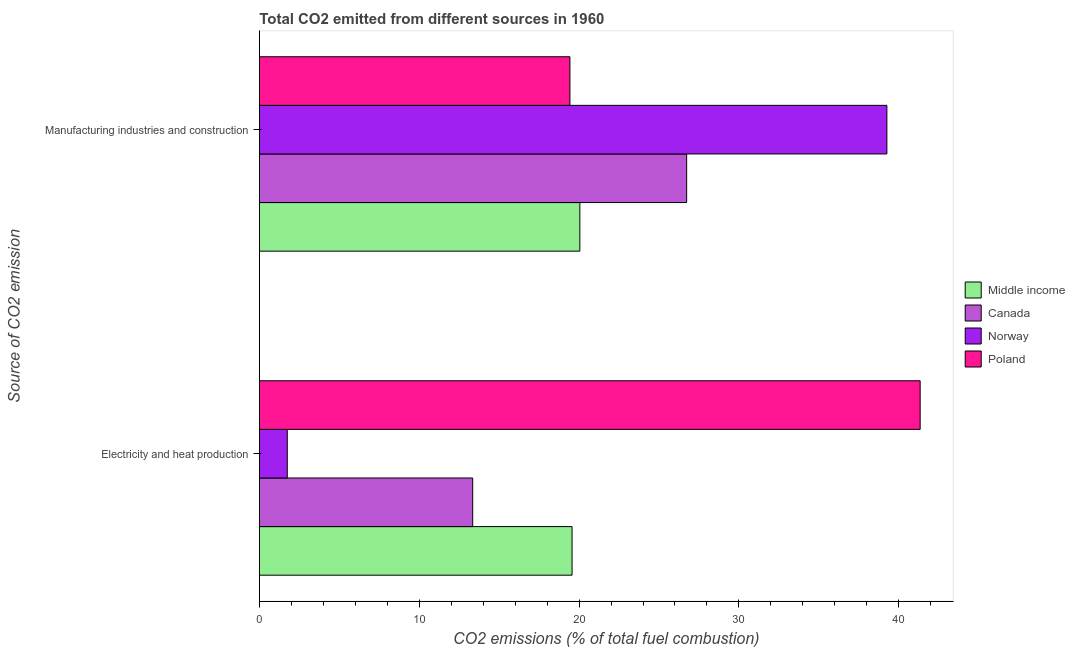How many groups of bars are there?
Your answer should be very brief. 2. Are the number of bars per tick equal to the number of legend labels?
Make the answer very short. Yes. Are the number of bars on each tick of the Y-axis equal?
Your response must be concise. Yes. How many bars are there on the 2nd tick from the top?
Provide a succinct answer. 4. What is the label of the 1st group of bars from the top?
Offer a terse response. Manufacturing industries and construction. What is the co2 emissions due to electricity and heat production in Norway?
Provide a succinct answer. 1.75. Across all countries, what is the maximum co2 emissions due to electricity and heat production?
Offer a very short reply. 41.34. Across all countries, what is the minimum co2 emissions due to electricity and heat production?
Provide a succinct answer. 1.75. What is the total co2 emissions due to manufacturing industries in the graph?
Keep it short and to the point. 105.46. What is the difference between the co2 emissions due to electricity and heat production in Middle income and that in Poland?
Offer a very short reply. -21.77. What is the difference between the co2 emissions due to electricity and heat production in Poland and the co2 emissions due to manufacturing industries in Norway?
Your answer should be compact. 2.08. What is the average co2 emissions due to electricity and heat production per country?
Ensure brevity in your answer.  19. What is the difference between the co2 emissions due to electricity and heat production and co2 emissions due to manufacturing industries in Poland?
Ensure brevity in your answer.  21.91. In how many countries, is the co2 emissions due to electricity and heat production greater than 28 %?
Give a very brief answer. 1. What is the ratio of the co2 emissions due to electricity and heat production in Middle income to that in Poland?
Your response must be concise. 0.47. Is the co2 emissions due to electricity and heat production in Poland less than that in Norway?
Provide a short and direct response. No. In how many countries, is the co2 emissions due to manufacturing industries greater than the average co2 emissions due to manufacturing industries taken over all countries?
Your answer should be very brief. 2. What does the 3rd bar from the top in Electricity and heat production represents?
Your answer should be compact. Canada. What does the 3rd bar from the bottom in Electricity and heat production represents?
Your answer should be very brief. Norway. Are all the bars in the graph horizontal?
Keep it short and to the point. Yes. How many countries are there in the graph?
Ensure brevity in your answer.  4. What is the difference between two consecutive major ticks on the X-axis?
Your response must be concise. 10. Are the values on the major ticks of X-axis written in scientific E-notation?
Offer a terse response. No. Does the graph contain any zero values?
Your response must be concise. No. How many legend labels are there?
Make the answer very short. 4. What is the title of the graph?
Your response must be concise. Total CO2 emitted from different sources in 1960. What is the label or title of the X-axis?
Make the answer very short. CO2 emissions (% of total fuel combustion). What is the label or title of the Y-axis?
Your response must be concise. Source of CO2 emission. What is the CO2 emissions (% of total fuel combustion) of Middle income in Electricity and heat production?
Your answer should be very brief. 19.56. What is the CO2 emissions (% of total fuel combustion) in Canada in Electricity and heat production?
Keep it short and to the point. 13.35. What is the CO2 emissions (% of total fuel combustion) in Norway in Electricity and heat production?
Provide a short and direct response. 1.75. What is the CO2 emissions (% of total fuel combustion) of Poland in Electricity and heat production?
Provide a short and direct response. 41.34. What is the CO2 emissions (% of total fuel combustion) in Middle income in Manufacturing industries and construction?
Give a very brief answer. 20.05. What is the CO2 emissions (% of total fuel combustion) in Canada in Manufacturing industries and construction?
Offer a terse response. 26.73. What is the CO2 emissions (% of total fuel combustion) of Norway in Manufacturing industries and construction?
Your answer should be compact. 39.26. What is the CO2 emissions (% of total fuel combustion) of Poland in Manufacturing industries and construction?
Give a very brief answer. 19.43. Across all Source of CO2 emission, what is the maximum CO2 emissions (% of total fuel combustion) of Middle income?
Offer a very short reply. 20.05. Across all Source of CO2 emission, what is the maximum CO2 emissions (% of total fuel combustion) in Canada?
Provide a short and direct response. 26.73. Across all Source of CO2 emission, what is the maximum CO2 emissions (% of total fuel combustion) of Norway?
Provide a succinct answer. 39.26. Across all Source of CO2 emission, what is the maximum CO2 emissions (% of total fuel combustion) of Poland?
Your answer should be very brief. 41.34. Across all Source of CO2 emission, what is the minimum CO2 emissions (% of total fuel combustion) of Middle income?
Provide a succinct answer. 19.56. Across all Source of CO2 emission, what is the minimum CO2 emissions (% of total fuel combustion) in Canada?
Keep it short and to the point. 13.35. Across all Source of CO2 emission, what is the minimum CO2 emissions (% of total fuel combustion) in Norway?
Ensure brevity in your answer.  1.75. Across all Source of CO2 emission, what is the minimum CO2 emissions (% of total fuel combustion) of Poland?
Provide a succinct answer. 19.43. What is the total CO2 emissions (% of total fuel combustion) in Middle income in the graph?
Keep it short and to the point. 39.61. What is the total CO2 emissions (% of total fuel combustion) in Canada in the graph?
Offer a terse response. 40.08. What is the total CO2 emissions (% of total fuel combustion) of Norway in the graph?
Make the answer very short. 41. What is the total CO2 emissions (% of total fuel combustion) in Poland in the graph?
Make the answer very short. 60.77. What is the difference between the CO2 emissions (% of total fuel combustion) in Middle income in Electricity and heat production and that in Manufacturing industries and construction?
Provide a short and direct response. -0.49. What is the difference between the CO2 emissions (% of total fuel combustion) of Canada in Electricity and heat production and that in Manufacturing industries and construction?
Provide a succinct answer. -13.38. What is the difference between the CO2 emissions (% of total fuel combustion) in Norway in Electricity and heat production and that in Manufacturing industries and construction?
Your answer should be very brief. -37.51. What is the difference between the CO2 emissions (% of total fuel combustion) in Poland in Electricity and heat production and that in Manufacturing industries and construction?
Your answer should be compact. 21.91. What is the difference between the CO2 emissions (% of total fuel combustion) of Middle income in Electricity and heat production and the CO2 emissions (% of total fuel combustion) of Canada in Manufacturing industries and construction?
Your answer should be compact. -7.17. What is the difference between the CO2 emissions (% of total fuel combustion) of Middle income in Electricity and heat production and the CO2 emissions (% of total fuel combustion) of Norway in Manufacturing industries and construction?
Offer a very short reply. -19.69. What is the difference between the CO2 emissions (% of total fuel combustion) in Middle income in Electricity and heat production and the CO2 emissions (% of total fuel combustion) in Poland in Manufacturing industries and construction?
Keep it short and to the point. 0.13. What is the difference between the CO2 emissions (% of total fuel combustion) in Canada in Electricity and heat production and the CO2 emissions (% of total fuel combustion) in Norway in Manufacturing industries and construction?
Your answer should be compact. -25.91. What is the difference between the CO2 emissions (% of total fuel combustion) in Canada in Electricity and heat production and the CO2 emissions (% of total fuel combustion) in Poland in Manufacturing industries and construction?
Provide a short and direct response. -6.08. What is the difference between the CO2 emissions (% of total fuel combustion) of Norway in Electricity and heat production and the CO2 emissions (% of total fuel combustion) of Poland in Manufacturing industries and construction?
Offer a terse response. -17.68. What is the average CO2 emissions (% of total fuel combustion) of Middle income per Source of CO2 emission?
Make the answer very short. 19.81. What is the average CO2 emissions (% of total fuel combustion) in Canada per Source of CO2 emission?
Keep it short and to the point. 20.04. What is the average CO2 emissions (% of total fuel combustion) in Norway per Source of CO2 emission?
Provide a short and direct response. 20.5. What is the average CO2 emissions (% of total fuel combustion) of Poland per Source of CO2 emission?
Offer a terse response. 30.38. What is the difference between the CO2 emissions (% of total fuel combustion) in Middle income and CO2 emissions (% of total fuel combustion) in Canada in Electricity and heat production?
Provide a short and direct response. 6.22. What is the difference between the CO2 emissions (% of total fuel combustion) in Middle income and CO2 emissions (% of total fuel combustion) in Norway in Electricity and heat production?
Your response must be concise. 17.82. What is the difference between the CO2 emissions (% of total fuel combustion) of Middle income and CO2 emissions (% of total fuel combustion) of Poland in Electricity and heat production?
Your answer should be very brief. -21.77. What is the difference between the CO2 emissions (% of total fuel combustion) in Canada and CO2 emissions (% of total fuel combustion) in Norway in Electricity and heat production?
Your response must be concise. 11.6. What is the difference between the CO2 emissions (% of total fuel combustion) in Canada and CO2 emissions (% of total fuel combustion) in Poland in Electricity and heat production?
Your answer should be very brief. -27.99. What is the difference between the CO2 emissions (% of total fuel combustion) of Norway and CO2 emissions (% of total fuel combustion) of Poland in Electricity and heat production?
Provide a short and direct response. -39.59. What is the difference between the CO2 emissions (% of total fuel combustion) of Middle income and CO2 emissions (% of total fuel combustion) of Canada in Manufacturing industries and construction?
Keep it short and to the point. -6.68. What is the difference between the CO2 emissions (% of total fuel combustion) of Middle income and CO2 emissions (% of total fuel combustion) of Norway in Manufacturing industries and construction?
Make the answer very short. -19.21. What is the difference between the CO2 emissions (% of total fuel combustion) of Middle income and CO2 emissions (% of total fuel combustion) of Poland in Manufacturing industries and construction?
Your answer should be very brief. 0.62. What is the difference between the CO2 emissions (% of total fuel combustion) in Canada and CO2 emissions (% of total fuel combustion) in Norway in Manufacturing industries and construction?
Give a very brief answer. -12.53. What is the difference between the CO2 emissions (% of total fuel combustion) of Canada and CO2 emissions (% of total fuel combustion) of Poland in Manufacturing industries and construction?
Offer a terse response. 7.3. What is the difference between the CO2 emissions (% of total fuel combustion) in Norway and CO2 emissions (% of total fuel combustion) in Poland in Manufacturing industries and construction?
Offer a very short reply. 19.83. What is the ratio of the CO2 emissions (% of total fuel combustion) in Middle income in Electricity and heat production to that in Manufacturing industries and construction?
Keep it short and to the point. 0.98. What is the ratio of the CO2 emissions (% of total fuel combustion) of Canada in Electricity and heat production to that in Manufacturing industries and construction?
Give a very brief answer. 0.5. What is the ratio of the CO2 emissions (% of total fuel combustion) in Norway in Electricity and heat production to that in Manufacturing industries and construction?
Give a very brief answer. 0.04. What is the ratio of the CO2 emissions (% of total fuel combustion) of Poland in Electricity and heat production to that in Manufacturing industries and construction?
Give a very brief answer. 2.13. What is the difference between the highest and the second highest CO2 emissions (% of total fuel combustion) in Middle income?
Your answer should be compact. 0.49. What is the difference between the highest and the second highest CO2 emissions (% of total fuel combustion) in Canada?
Your response must be concise. 13.38. What is the difference between the highest and the second highest CO2 emissions (% of total fuel combustion) of Norway?
Your response must be concise. 37.51. What is the difference between the highest and the second highest CO2 emissions (% of total fuel combustion) of Poland?
Ensure brevity in your answer.  21.91. What is the difference between the highest and the lowest CO2 emissions (% of total fuel combustion) in Middle income?
Your answer should be compact. 0.49. What is the difference between the highest and the lowest CO2 emissions (% of total fuel combustion) of Canada?
Ensure brevity in your answer.  13.38. What is the difference between the highest and the lowest CO2 emissions (% of total fuel combustion) of Norway?
Provide a succinct answer. 37.51. What is the difference between the highest and the lowest CO2 emissions (% of total fuel combustion) of Poland?
Make the answer very short. 21.91. 